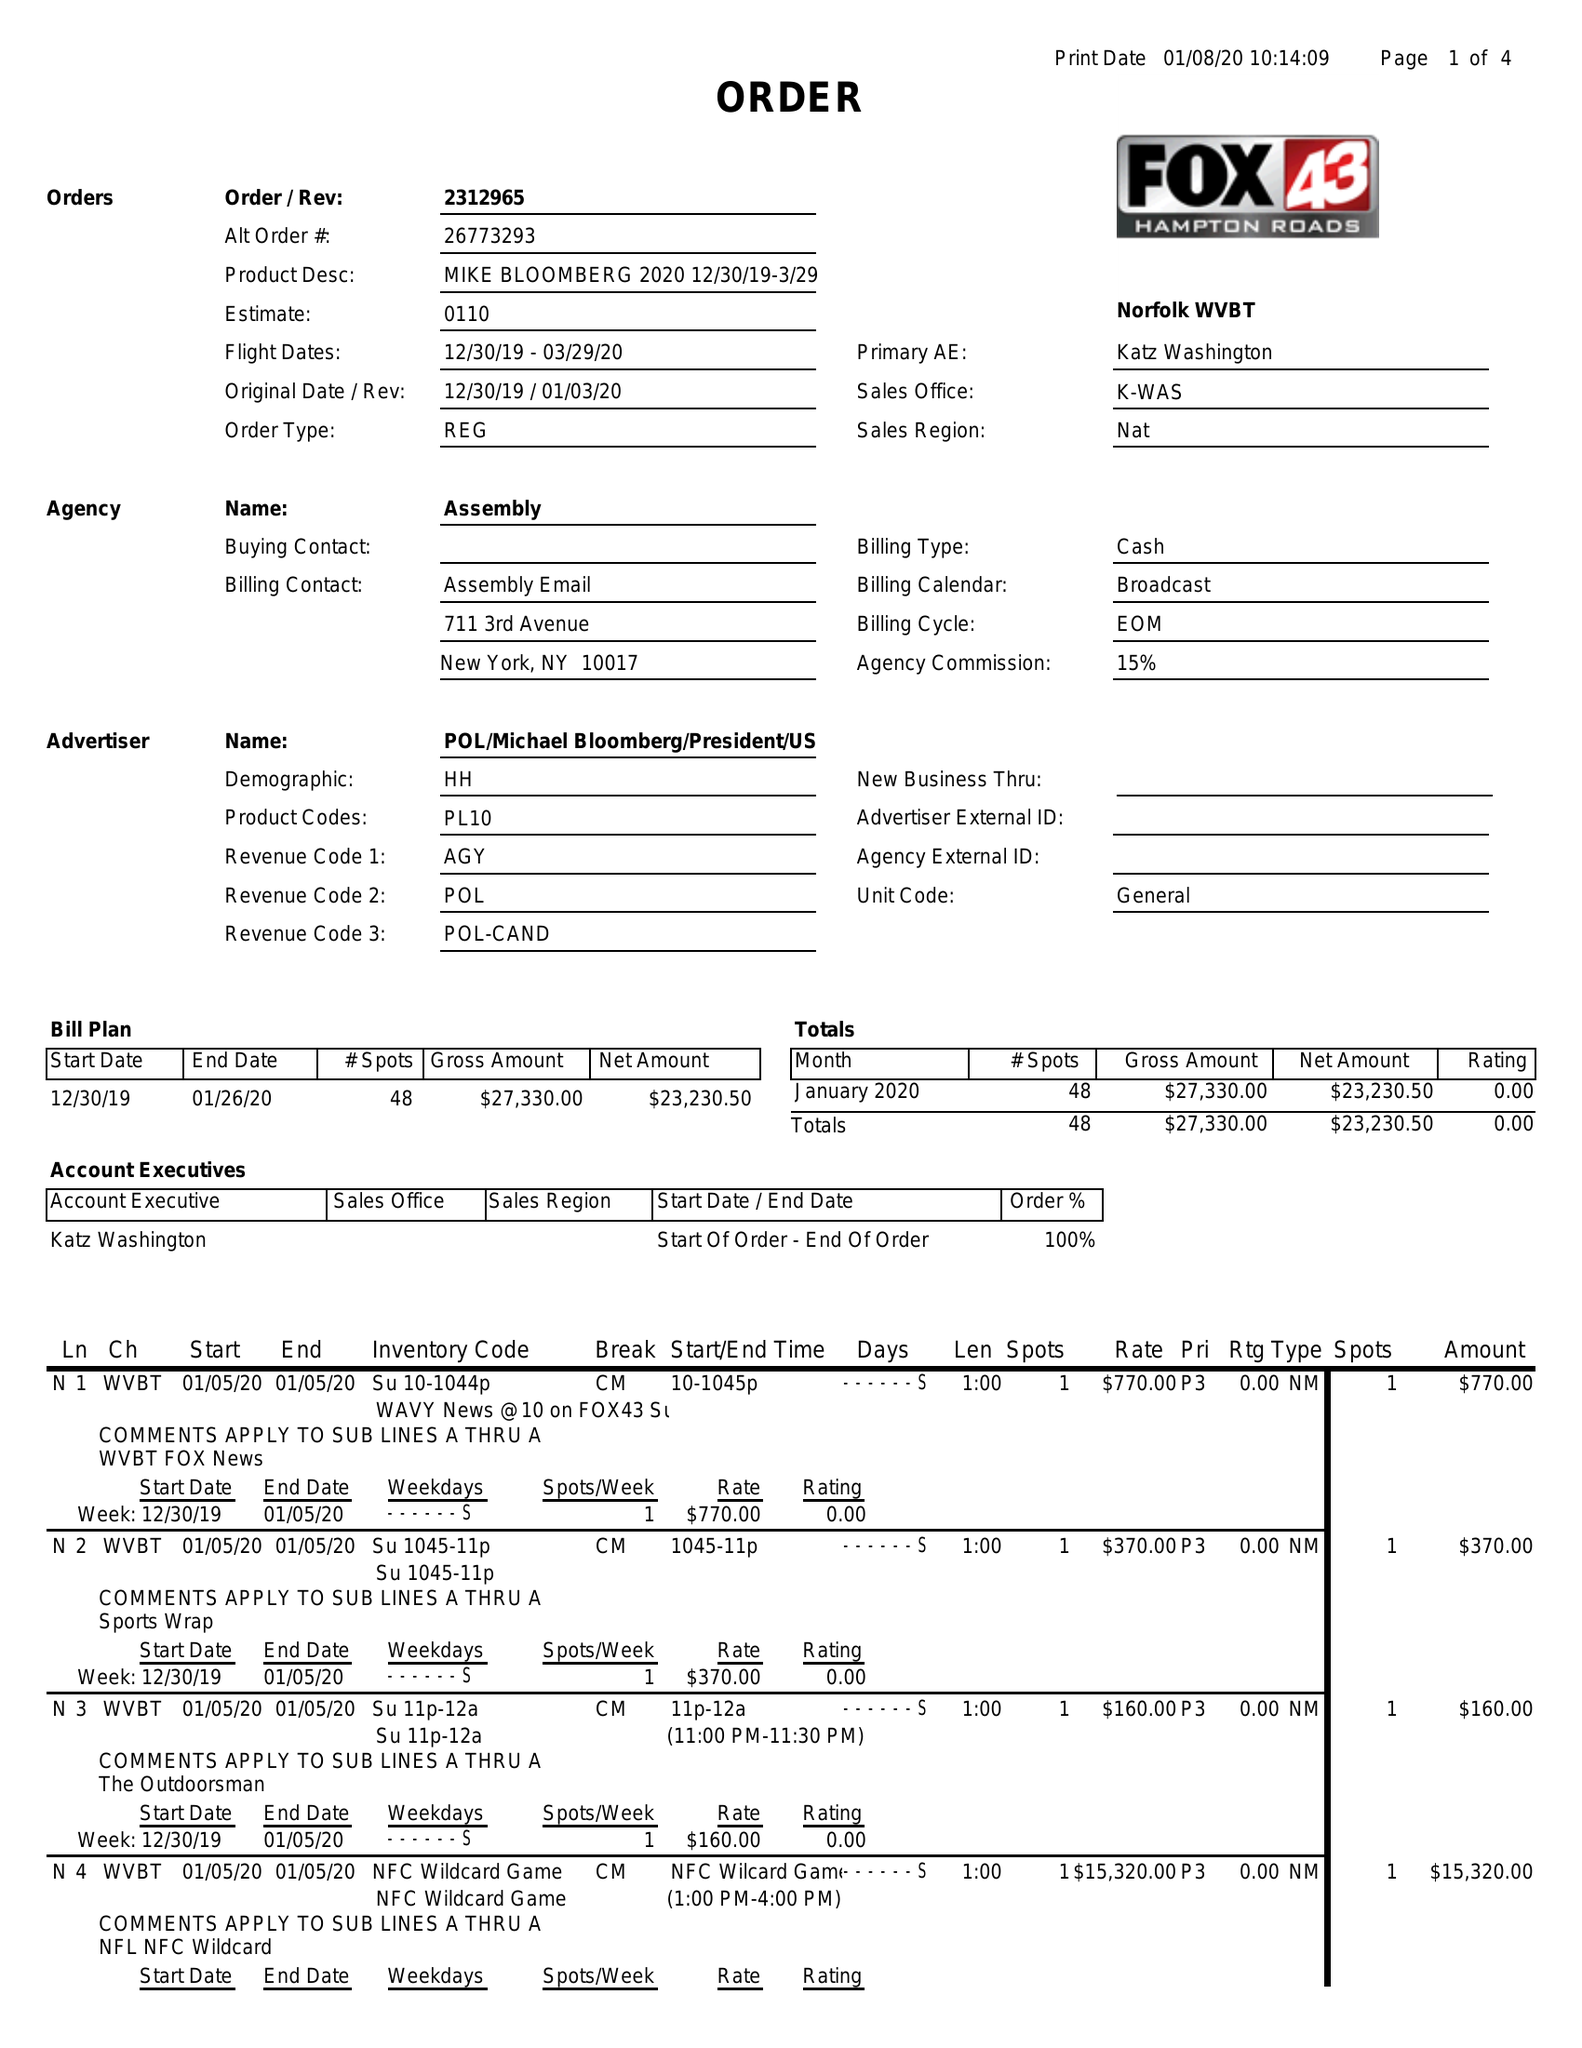What is the value for the gross_amount?
Answer the question using a single word or phrase. 27330.00 